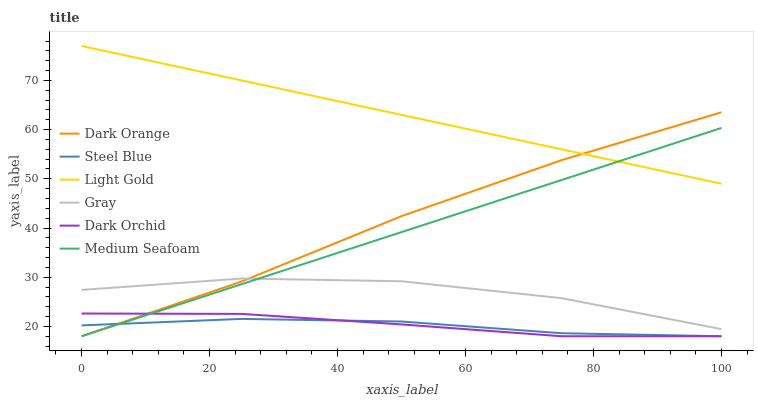Does Steel Blue have the minimum area under the curve?
Answer yes or no. Yes. Does Light Gold have the maximum area under the curve?
Answer yes or no. Yes. Does Gray have the minimum area under the curve?
Answer yes or no. No. Does Gray have the maximum area under the curve?
Answer yes or no. No. Is Medium Seafoam the smoothest?
Answer yes or no. Yes. Is Gray the roughest?
Answer yes or no. Yes. Is Steel Blue the smoothest?
Answer yes or no. No. Is Steel Blue the roughest?
Answer yes or no. No. Does Dark Orange have the lowest value?
Answer yes or no. Yes. Does Gray have the lowest value?
Answer yes or no. No. Does Light Gold have the highest value?
Answer yes or no. Yes. Does Gray have the highest value?
Answer yes or no. No. Is Gray less than Light Gold?
Answer yes or no. Yes. Is Gray greater than Steel Blue?
Answer yes or no. Yes. Does Medium Seafoam intersect Gray?
Answer yes or no. Yes. Is Medium Seafoam less than Gray?
Answer yes or no. No. Is Medium Seafoam greater than Gray?
Answer yes or no. No. Does Gray intersect Light Gold?
Answer yes or no. No. 